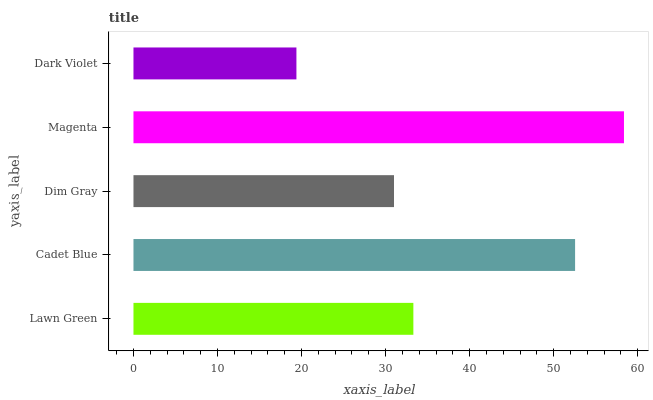Is Dark Violet the minimum?
Answer yes or no. Yes. Is Magenta the maximum?
Answer yes or no. Yes. Is Cadet Blue the minimum?
Answer yes or no. No. Is Cadet Blue the maximum?
Answer yes or no. No. Is Cadet Blue greater than Lawn Green?
Answer yes or no. Yes. Is Lawn Green less than Cadet Blue?
Answer yes or no. Yes. Is Lawn Green greater than Cadet Blue?
Answer yes or no. No. Is Cadet Blue less than Lawn Green?
Answer yes or no. No. Is Lawn Green the high median?
Answer yes or no. Yes. Is Lawn Green the low median?
Answer yes or no. Yes. Is Cadet Blue the high median?
Answer yes or no. No. Is Cadet Blue the low median?
Answer yes or no. No. 